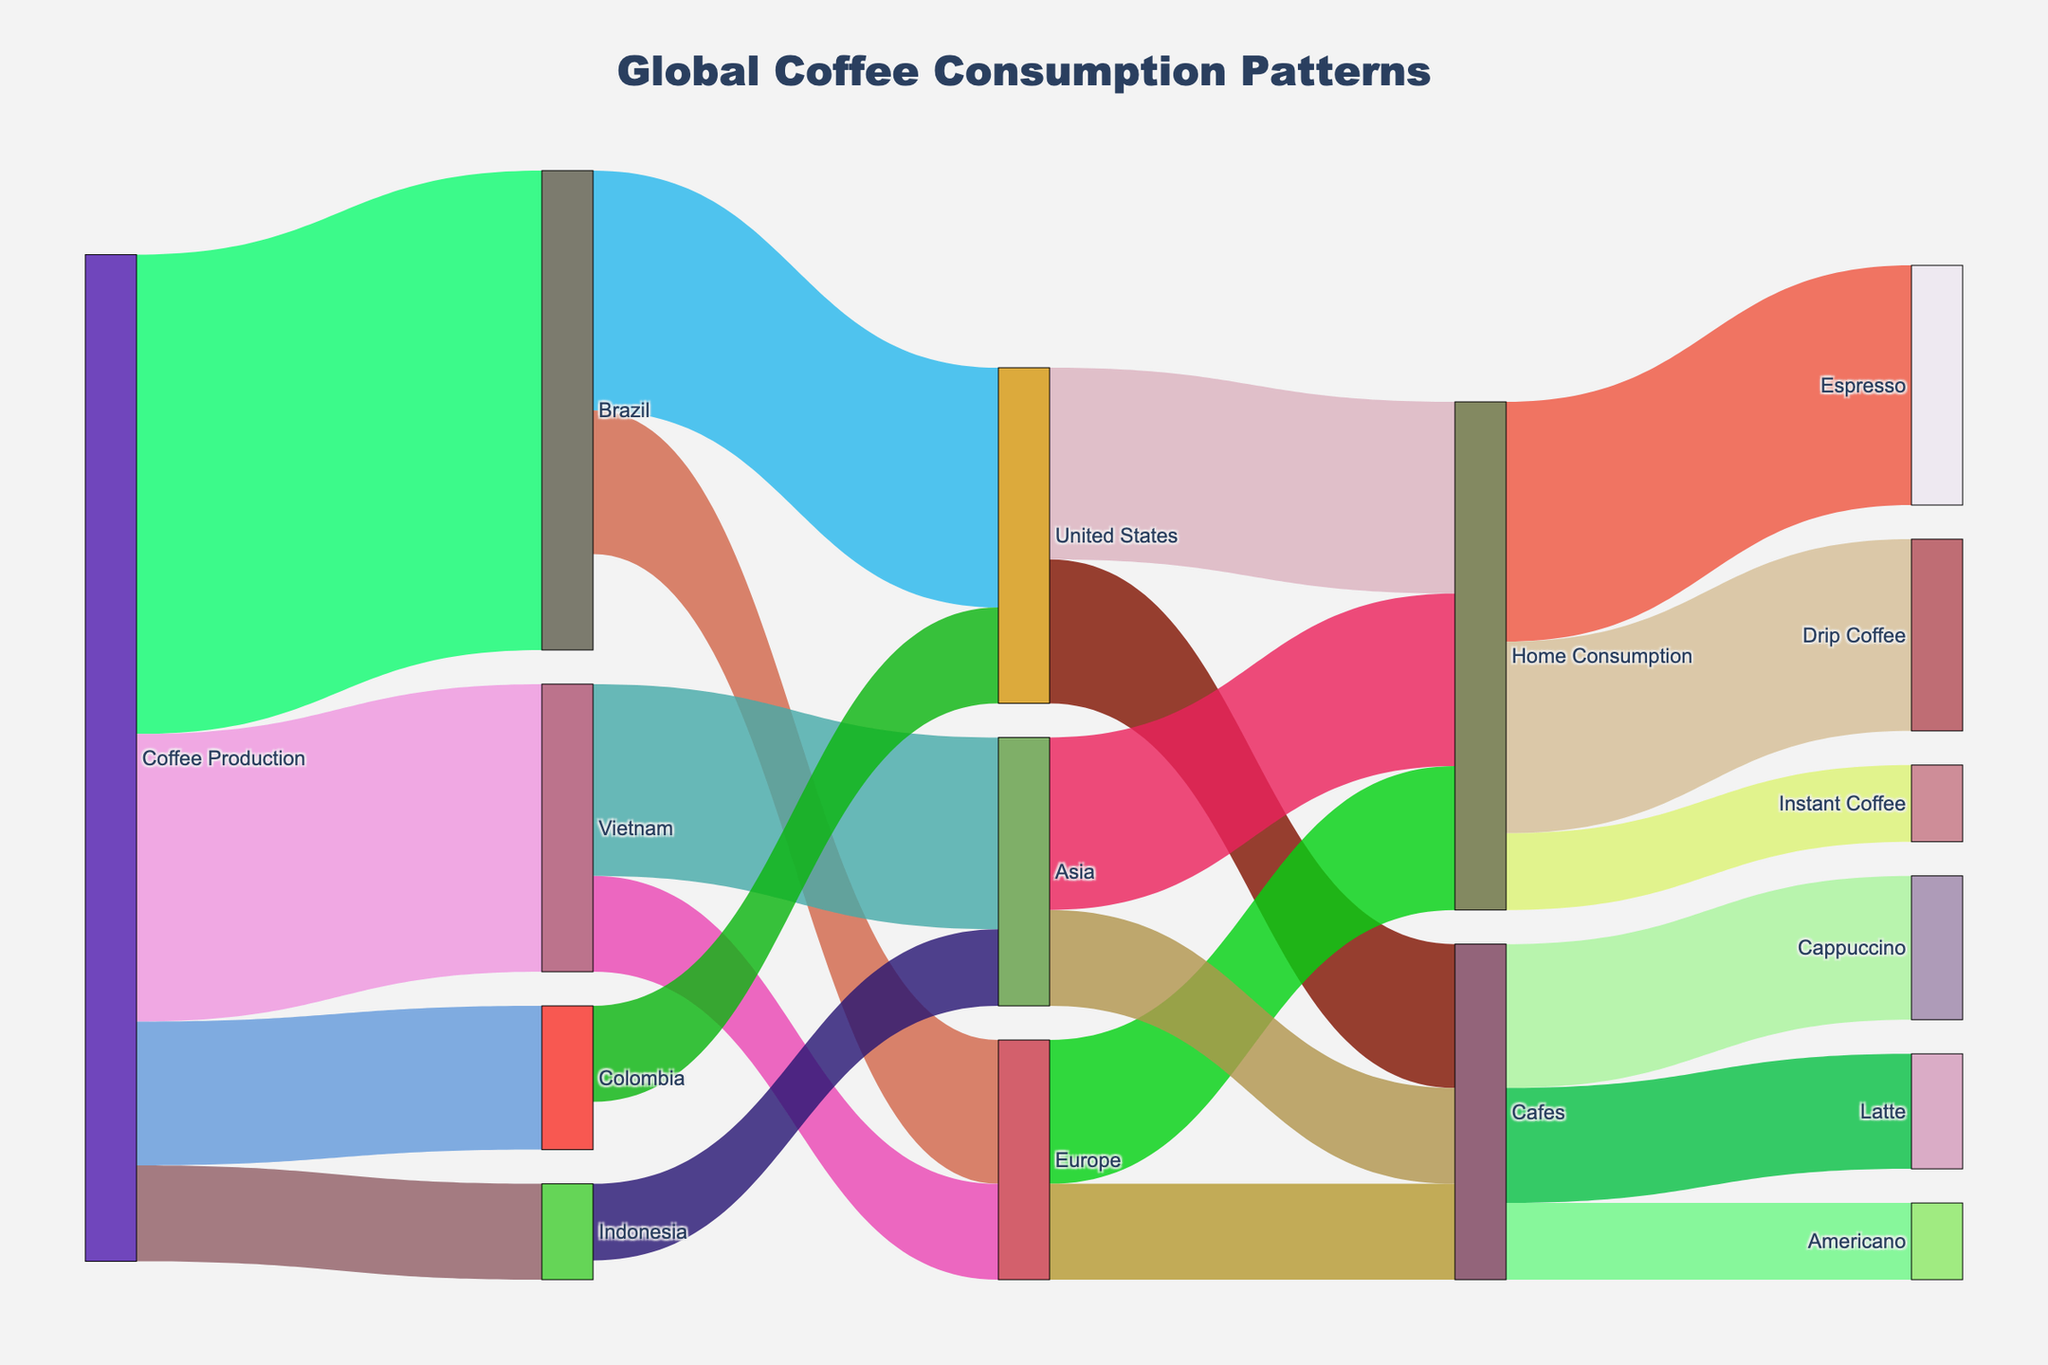Who is the largest coffee producer? The largest coffee producer can be identified by looking at the width of the flow from "Coffee Production" to various countries. The largest flow is to Brazil.
Answer: Brazil Which region consumes the most coffee at home? To find this, look at the flows from "Home Consumption" to different regions. The flow from "Home Consumption" to "Espresso" is the largest, indicating high home consumption in associated regions. Aggregating home consumption across all regions confirms Europe consumes the most at home.
Answer: Europe What types of coffee are most consumed in cafes? Types of coffee consumed in cafes can be identified by looking at the flows from "Cafes" to specific types of coffee. The largest flows are to Cappuccino and Latte.
Answer: Cappuccino and Latte How much coffee does the United States import from Brazil? To find the amount imported, look at the link connecting "Brazil" to "United States". The flow value is 25 units.
Answer: 25 units How does coffee consumption in Asia compare to Europe? To compare, sum up the flows to "Home Consumption" and "Cafes" for both Asia and Europe. Asia has flows of 18 and 10 (total 28) while Europe has 15 and 10 (total 25). Asia consumes more overall.
Answer: Asia consumes more Which coffee consumption type is the least among Home Consumption? The least consumed type in home consumption can be identified by examining the flows from "Home Consumption" to different coffee types. The smallest flow is to "Instant Coffee".
Answer: Instant Coffee What is the total coffee consumption by Home Consumption and Cafes in the United States? To get the total, sum the flows from "United States" to "Home Consumption" and "Cafes". The values are 20 and 15, respectively, giving a total of 35.
Answer: 35 From which country does Europe import most of its coffee? Check the flows from countries to "Europe". Brazil has the largest flow to Europe with 15 units.
Answer: Brazil What is the total production of coffee across all countries? To find the total production, sum the flows from "Coffee Production" to all the countries. The values are 50 (Brazil) + 30 (Vietnam) + 15 (Colombia) + 10 (Indonesia) = 105 units.
Answer: 105 units Which country is the third largest coffee producer? The third largest producer can be found by ranking the flow values from "Coffee Production" to different countries. The flows are 50 (Brazil), 30 (Vietnam), and 15 (Colombia). Colombia is the third largest.
Answer: Colombia 